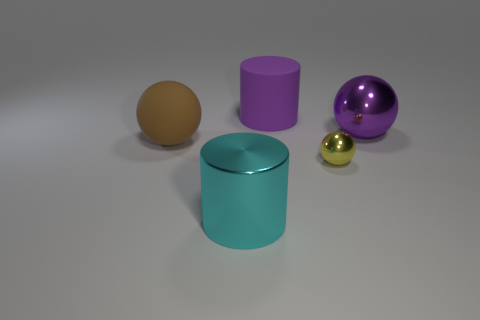There is a shiny sphere that is the same color as the big rubber cylinder; what is its size?
Your answer should be compact. Large. How many rubber things are either yellow balls or small green spheres?
Your answer should be compact. 0. There is a big object that is on the right side of the shiny ball in front of the big matte ball; is there a big metallic ball behind it?
Your response must be concise. No. There is a yellow thing; how many purple cylinders are to the left of it?
Your answer should be very brief. 1. There is a thing that is the same color as the matte cylinder; what is its material?
Your response must be concise. Metal. What number of big objects are either yellow shiny objects or yellow matte cylinders?
Provide a succinct answer. 0. There is a thing left of the shiny cylinder; what shape is it?
Your answer should be very brief. Sphere. Is there another small shiny thing of the same color as the tiny shiny object?
Your response must be concise. No. Do the cylinder behind the large cyan shiny cylinder and the cylinder that is in front of the big brown matte ball have the same size?
Provide a succinct answer. Yes. Is the number of large cyan metal cylinders that are to the left of the cyan metallic object greater than the number of large brown matte spheres that are in front of the tiny metal object?
Make the answer very short. No. 